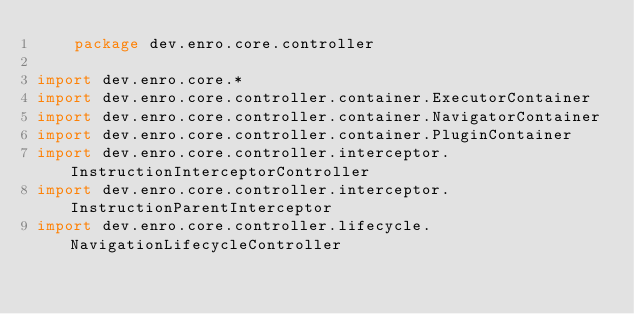Convert code to text. <code><loc_0><loc_0><loc_500><loc_500><_Kotlin_>    package dev.enro.core.controller

import dev.enro.core.*
import dev.enro.core.controller.container.ExecutorContainer
import dev.enro.core.controller.container.NavigatorContainer
import dev.enro.core.controller.container.PluginContainer
import dev.enro.core.controller.interceptor.InstructionInterceptorController
import dev.enro.core.controller.interceptor.InstructionParentInterceptor
import dev.enro.core.controller.lifecycle.NavigationLifecycleController</code> 